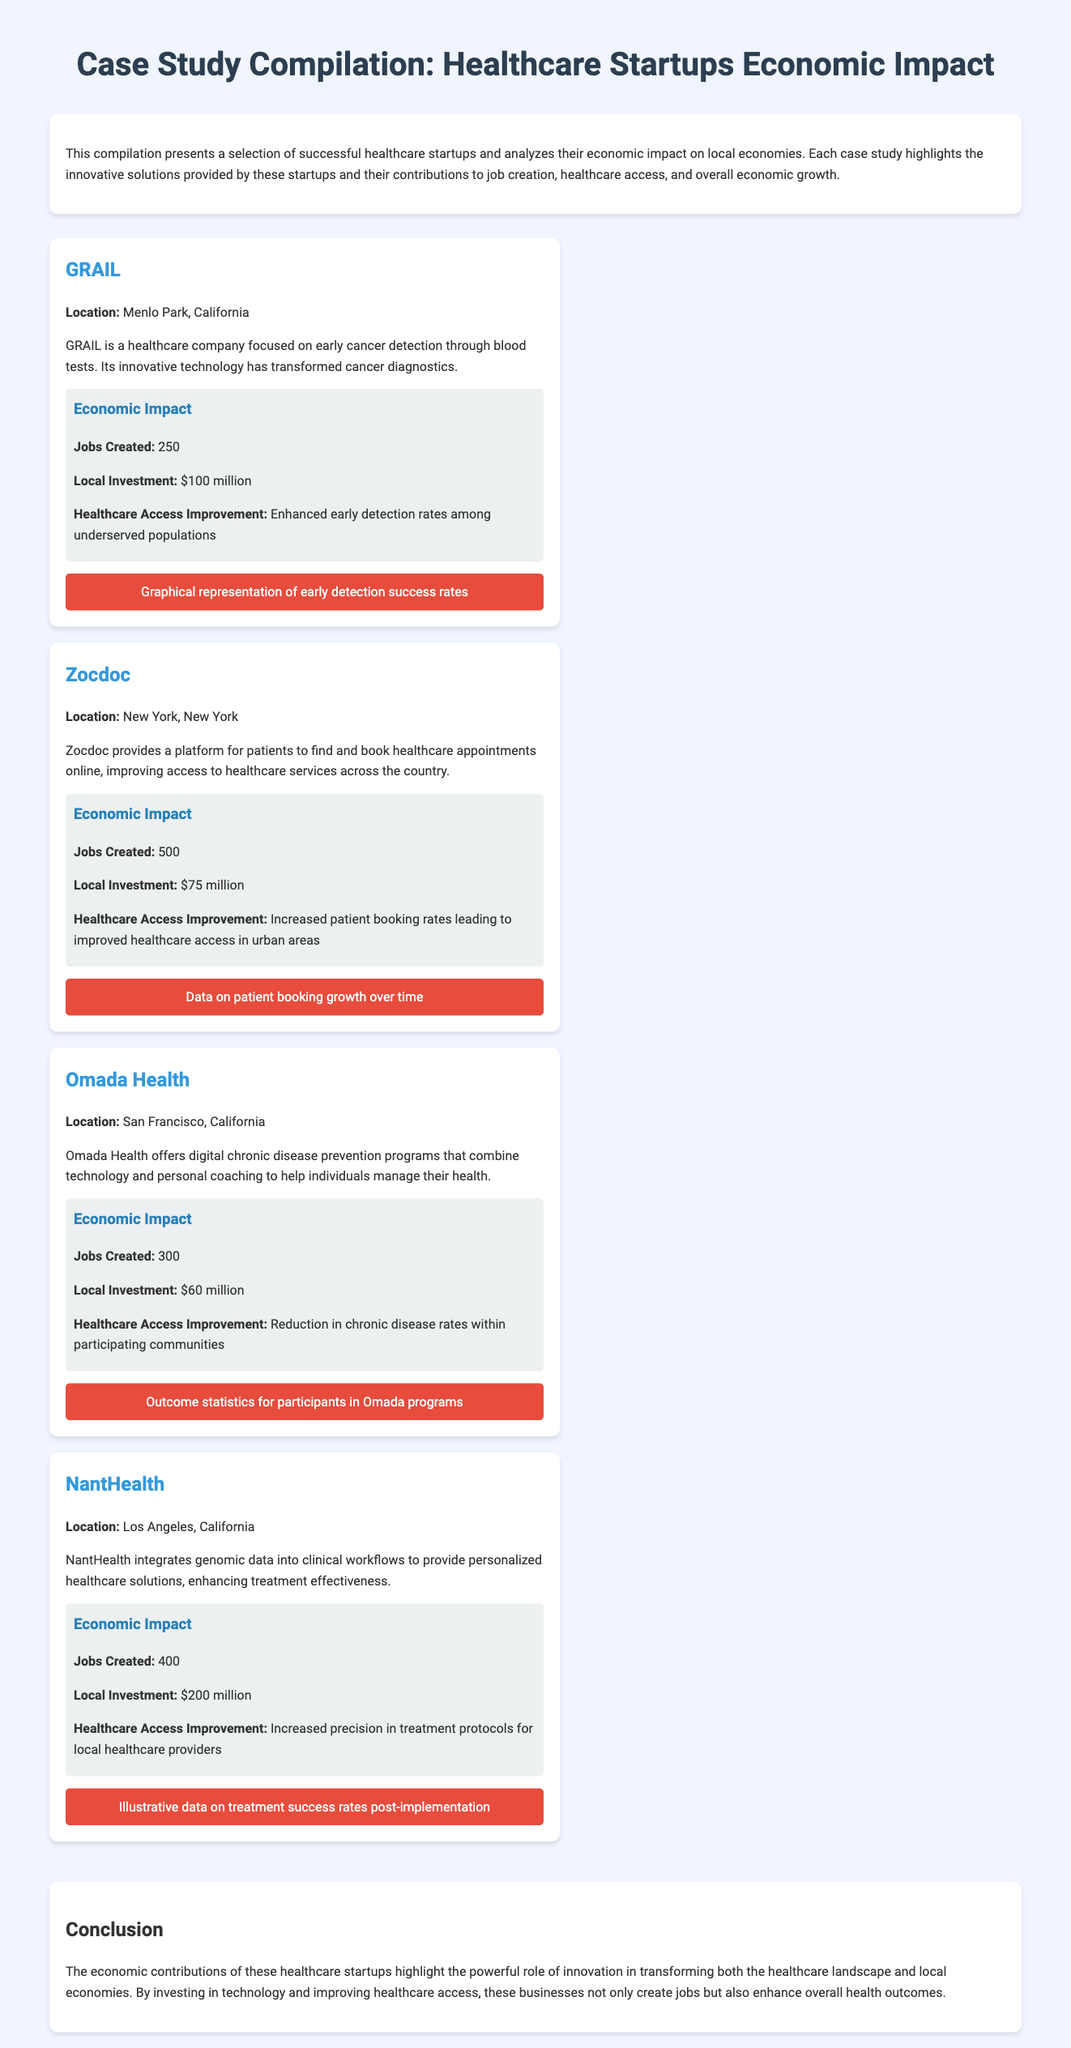What is the location of GRAIL? The document states that GRAIL is located in Menlo Park, California.
Answer: Menlo Park, California How many jobs were created by Zocdoc? According to the case study on Zocdoc, it created 500 jobs.
Answer: 500 What is the local investment made by Omada Health? The document mentions that Omada Health made a local investment of $60 million.
Answer: $60 million What improvement did NantHealth provide in healthcare access? NantHealth increased precision in treatment protocols for local healthcare providers as noted in the document.
Answer: Increased precision in treatment protocols Which startup focuses on early cancer detection? GRAIL is the startup that focuses on early cancer detection as per the document.
Answer: GRAIL How many jobs did Omada Health create? The case study on Omada Health indicates that it created 300 jobs.
Answer: 300 What type of data does NantHealth integrate into clinical workflows? The document indicates that NantHealth integrates genomic data into clinical workflows.
Answer: Genomic data Which startup had the highest local investment? Based on the case studies, NantHealth had the highest local investment of $200 million.
Answer: $200 million 